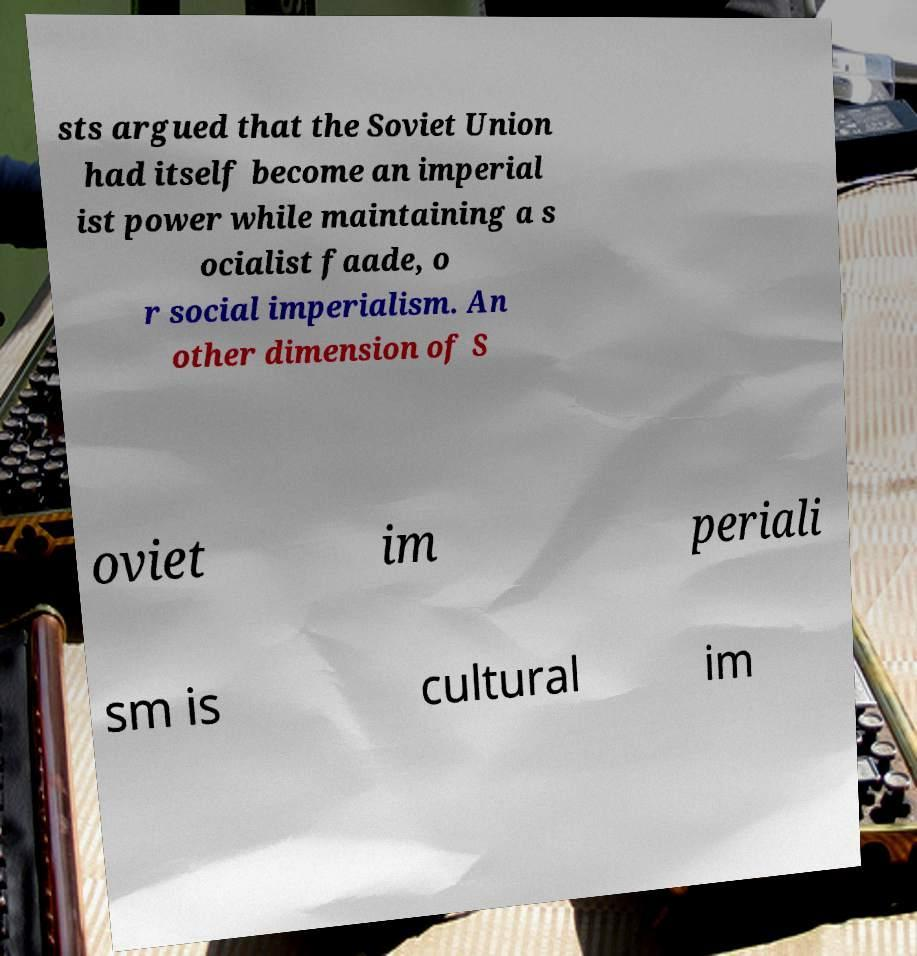Can you accurately transcribe the text from the provided image for me? sts argued that the Soviet Union had itself become an imperial ist power while maintaining a s ocialist faade, o r social imperialism. An other dimension of S oviet im periali sm is cultural im 